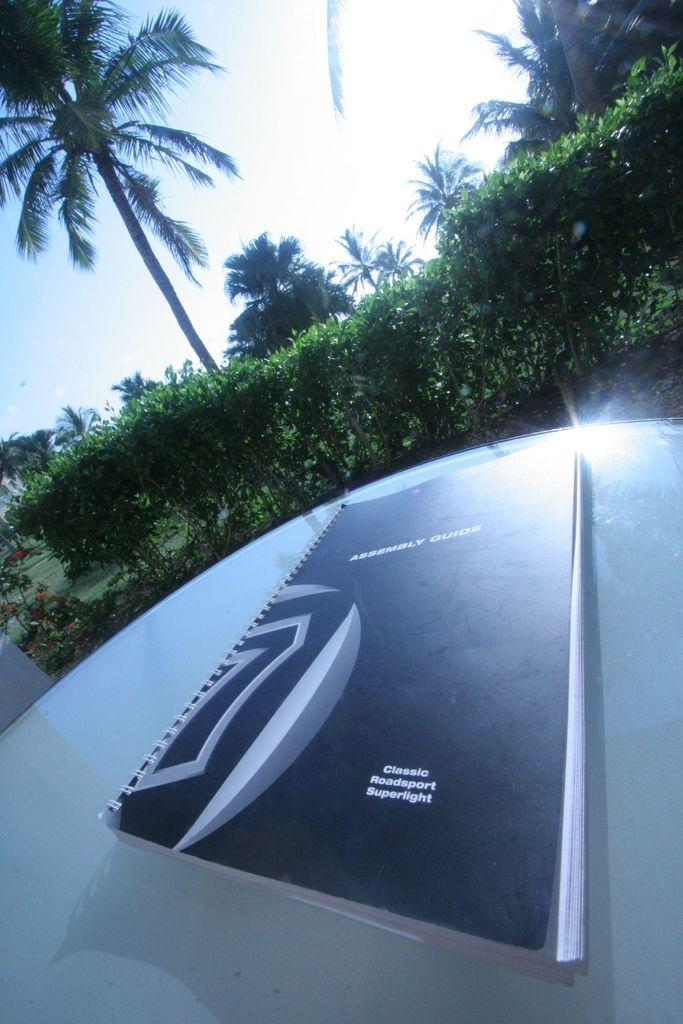What object is placed on the table in the image? There is a book on a table in the image. What type of vegetation can be seen in the middle of the image? There are bushes in the middle of the image. What other type of vegetation is present in the image? There are trees in the image. What type of silk is draped over the bushes in the image? There is no silk present in the image; it only features bushes and trees. 